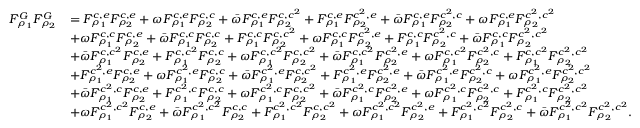<formula> <loc_0><loc_0><loc_500><loc_500>\begin{array} { r l } { F _ { \rho _ { 1 } } ^ { G } F _ { \rho _ { 2 } } ^ { G } } & { = F _ { \rho _ { 1 } } ^ { c , e } F _ { \rho _ { 2 } } ^ { c , e } + \omega F _ { \rho _ { 1 } } ^ { c , e } F _ { \rho _ { 2 } } ^ { c , c } + \bar { \omega } F _ { \rho _ { 1 } } ^ { c , e } F _ { \rho _ { 2 } } ^ { c , c ^ { 2 } } + F _ { \rho _ { 1 } } ^ { c , e } F _ { \rho _ { 2 } } ^ { c ^ { 2 } , e } + \bar { \omega } F _ { \rho _ { 1 } } ^ { c , e } F _ { \rho _ { 2 } } ^ { c ^ { 2 } , c } + \omega F _ { \rho _ { 1 } } ^ { c , e } F _ { \rho _ { 2 } } ^ { c ^ { 2 } , c ^ { 2 } } } \\ & { + \omega F _ { \rho _ { 1 } } ^ { c , c } F _ { \rho _ { 2 } } ^ { c , e } + \bar { \omega } F _ { \rho _ { 1 } } ^ { c , c } F _ { \rho _ { 2 } } ^ { c , c } + F _ { \rho _ { 1 } } ^ { c , c } F _ { \rho _ { 2 } } ^ { c , c ^ { 2 } } + \omega F _ { \rho _ { 1 } } ^ { c , c } F _ { \rho _ { 2 } } ^ { c ^ { 2 } , e } + F _ { \rho _ { 1 } } ^ { c , c } F _ { \rho _ { 2 } } ^ { c ^ { 2 } , c } + \bar { \omega } F _ { \rho _ { 1 } } ^ { c , c } F _ { \rho _ { 2 } } ^ { c ^ { 2 } , c ^ { 2 } } } \\ & { + \bar { \omega } F _ { \rho _ { 1 } } ^ { c , c ^ { 2 } } F _ { \rho _ { 2 } } ^ { c , e } + F _ { \rho _ { 1 } } ^ { c , c ^ { 2 } } F _ { \rho _ { 2 } } ^ { c , c } + \omega F _ { \rho _ { 1 } } ^ { c , c ^ { 2 } } F _ { \rho _ { 2 } } ^ { c , c ^ { 2 } } + \bar { \omega } F _ { \rho _ { 1 } } ^ { c , c ^ { 2 } } F _ { \rho _ { 2 } } ^ { c ^ { 2 } , e } + \omega F _ { \rho _ { 1 } } ^ { c , c ^ { 2 } } F _ { \rho _ { 2 } } ^ { c ^ { 2 } , c } + F _ { \rho _ { 1 } } ^ { c , c ^ { 2 } } F _ { \rho _ { 2 } } ^ { c ^ { 2 } , c ^ { 2 } } } \\ & { + F _ { \rho _ { 1 } } ^ { c ^ { 2 } , e } F _ { \rho _ { 2 } } ^ { c , e } + \omega F _ { \rho _ { 1 } } ^ { c ^ { 2 } , e } F _ { \rho _ { 2 } } ^ { c , c } + \bar { \omega } F _ { \rho _ { 1 } } ^ { c ^ { 2 } , e } F _ { \rho _ { 2 } } ^ { c , c ^ { 2 } } + F _ { \rho _ { 1 } } ^ { c ^ { 2 } , e } F _ { \rho _ { 2 } } ^ { c ^ { 2 } , e } + \bar { \omega } F _ { \rho _ { 1 } } ^ { c ^ { 2 } , e } F _ { \rho _ { 2 } } ^ { c ^ { 2 } , c } + \omega F _ { \rho _ { 1 } } ^ { c ^ { 2 } , e } F _ { \rho _ { 2 } } ^ { c ^ { 2 } , c ^ { 2 } } } \\ & { + \bar { \omega } F _ { \rho _ { 1 } } ^ { c ^ { 2 } , c } F _ { \rho _ { 2 } } ^ { c , e } + F _ { \rho _ { 1 } } ^ { c ^ { 2 } , c } F _ { \rho _ { 2 } } ^ { c , c } + \omega F _ { \rho _ { 1 } } ^ { c ^ { 2 } , c } F _ { \rho _ { 2 } } ^ { c , c ^ { 2 } } + \bar { \omega } F _ { \rho _ { 1 } } ^ { c ^ { 2 } , c } F _ { \rho _ { 2 } } ^ { c ^ { 2 } , e } + \omega F _ { \rho _ { 1 } } ^ { c ^ { 2 } , c } F _ { \rho _ { 2 } } ^ { c ^ { 2 } , c } + F _ { \rho _ { 1 } } ^ { c ^ { 2 } , c } F _ { \rho _ { 2 } } ^ { c ^ { 2 } , c ^ { 2 } } } \\ & { + \omega F _ { \rho _ { 1 } } ^ { c ^ { 2 } , c ^ { 2 } } F _ { \rho _ { 2 } } ^ { c , e } + \bar { \omega } F _ { \rho _ { 1 } } ^ { c ^ { 2 } , c ^ { 2 } } F _ { \rho _ { 2 } } ^ { c , c } + F _ { \rho _ { 1 } } ^ { c ^ { 2 } , c ^ { 2 } } F _ { \rho _ { 2 } } ^ { c , c ^ { 2 } } + \omega F _ { \rho _ { 1 } } ^ { c ^ { 2 } , c ^ { 2 } } F _ { \rho _ { 2 } } ^ { c ^ { 2 } , e } + F _ { \rho _ { 1 } } ^ { c ^ { 2 } , c ^ { 2 } } F _ { \rho _ { 2 } } ^ { c ^ { 2 } , c } + \bar { \omega } F _ { \rho _ { 1 } } ^ { c ^ { 2 } , c ^ { 2 } } F _ { \rho _ { 2 } } ^ { c ^ { 2 } , c ^ { 2 } } . } \end{array}</formula> 